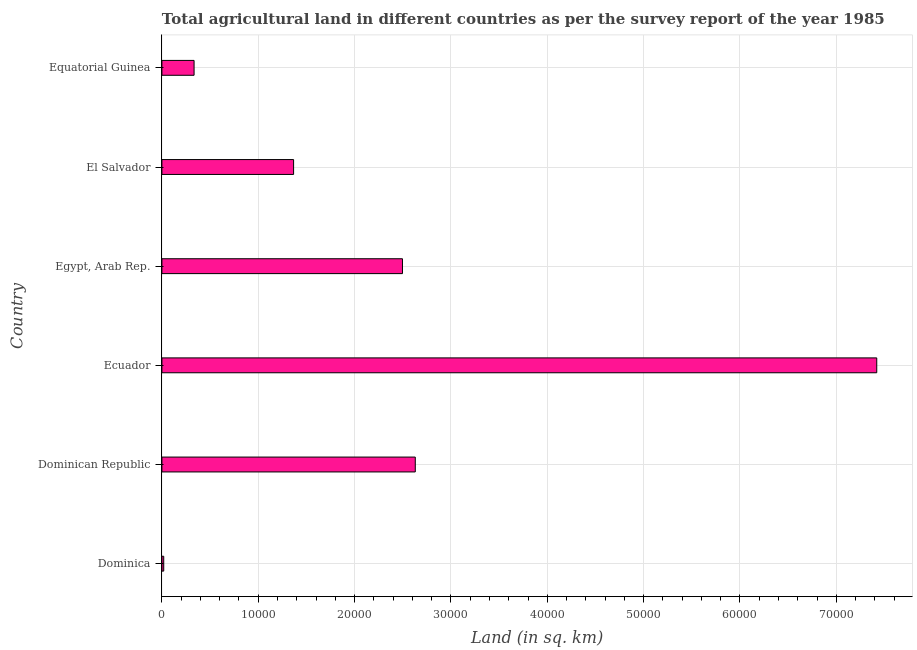Does the graph contain any zero values?
Give a very brief answer. No. What is the title of the graph?
Your response must be concise. Total agricultural land in different countries as per the survey report of the year 1985. What is the label or title of the X-axis?
Provide a short and direct response. Land (in sq. km). What is the agricultural land in El Salvador?
Offer a very short reply. 1.37e+04. Across all countries, what is the maximum agricultural land?
Make the answer very short. 7.42e+04. Across all countries, what is the minimum agricultural land?
Keep it short and to the point. 190. In which country was the agricultural land maximum?
Make the answer very short. Ecuador. In which country was the agricultural land minimum?
Provide a succinct answer. Dominica. What is the sum of the agricultural land?
Offer a very short reply. 1.43e+05. What is the difference between the agricultural land in Dominican Republic and El Salvador?
Provide a succinct answer. 1.26e+04. What is the average agricultural land per country?
Ensure brevity in your answer.  2.38e+04. What is the median agricultural land?
Offer a very short reply. 1.93e+04. In how many countries, is the agricultural land greater than 42000 sq. km?
Provide a succinct answer. 1. What is the ratio of the agricultural land in Egypt, Arab Rep. to that in El Salvador?
Offer a very short reply. 1.83. Is the agricultural land in Dominican Republic less than that in El Salvador?
Your answer should be very brief. No. What is the difference between the highest and the second highest agricultural land?
Keep it short and to the point. 4.79e+04. Is the sum of the agricultural land in Egypt, Arab Rep. and El Salvador greater than the maximum agricultural land across all countries?
Keep it short and to the point. No. What is the difference between the highest and the lowest agricultural land?
Provide a short and direct response. 7.40e+04. Are all the bars in the graph horizontal?
Give a very brief answer. Yes. What is the Land (in sq. km) in Dominica?
Give a very brief answer. 190. What is the Land (in sq. km) of Dominican Republic?
Provide a succinct answer. 2.63e+04. What is the Land (in sq. km) of Ecuador?
Your answer should be compact. 7.42e+04. What is the Land (in sq. km) of Egypt, Arab Rep.?
Your answer should be compact. 2.50e+04. What is the Land (in sq. km) in El Salvador?
Keep it short and to the point. 1.37e+04. What is the Land (in sq. km) of Equatorial Guinea?
Give a very brief answer. 3340. What is the difference between the Land (in sq. km) in Dominica and Dominican Republic?
Your response must be concise. -2.61e+04. What is the difference between the Land (in sq. km) in Dominica and Ecuador?
Provide a succinct answer. -7.40e+04. What is the difference between the Land (in sq. km) in Dominica and Egypt, Arab Rep.?
Give a very brief answer. -2.48e+04. What is the difference between the Land (in sq. km) in Dominica and El Salvador?
Your answer should be very brief. -1.35e+04. What is the difference between the Land (in sq. km) in Dominica and Equatorial Guinea?
Your answer should be compact. -3150. What is the difference between the Land (in sq. km) in Dominican Republic and Ecuador?
Give a very brief answer. -4.79e+04. What is the difference between the Land (in sq. km) in Dominican Republic and Egypt, Arab Rep.?
Provide a succinct answer. 1330. What is the difference between the Land (in sq. km) in Dominican Republic and El Salvador?
Keep it short and to the point. 1.26e+04. What is the difference between the Land (in sq. km) in Dominican Republic and Equatorial Guinea?
Provide a succinct answer. 2.30e+04. What is the difference between the Land (in sq. km) in Ecuador and Egypt, Arab Rep.?
Make the answer very short. 4.92e+04. What is the difference between the Land (in sq. km) in Ecuador and El Salvador?
Your response must be concise. 6.05e+04. What is the difference between the Land (in sq. km) in Ecuador and Equatorial Guinea?
Your response must be concise. 7.09e+04. What is the difference between the Land (in sq. km) in Egypt, Arab Rep. and El Salvador?
Give a very brief answer. 1.13e+04. What is the difference between the Land (in sq. km) in Egypt, Arab Rep. and Equatorial Guinea?
Keep it short and to the point. 2.16e+04. What is the difference between the Land (in sq. km) in El Salvador and Equatorial Guinea?
Your answer should be compact. 1.03e+04. What is the ratio of the Land (in sq. km) in Dominica to that in Dominican Republic?
Offer a very short reply. 0.01. What is the ratio of the Land (in sq. km) in Dominica to that in Ecuador?
Your answer should be very brief. 0. What is the ratio of the Land (in sq. km) in Dominica to that in Egypt, Arab Rep.?
Your response must be concise. 0.01. What is the ratio of the Land (in sq. km) in Dominica to that in El Salvador?
Ensure brevity in your answer.  0.01. What is the ratio of the Land (in sq. km) in Dominica to that in Equatorial Guinea?
Offer a terse response. 0.06. What is the ratio of the Land (in sq. km) in Dominican Republic to that in Ecuador?
Provide a succinct answer. 0.35. What is the ratio of the Land (in sq. km) in Dominican Republic to that in Egypt, Arab Rep.?
Your answer should be compact. 1.05. What is the ratio of the Land (in sq. km) in Dominican Republic to that in El Salvador?
Your response must be concise. 1.92. What is the ratio of the Land (in sq. km) in Dominican Republic to that in Equatorial Guinea?
Make the answer very short. 7.87. What is the ratio of the Land (in sq. km) in Ecuador to that in Egypt, Arab Rep.?
Provide a succinct answer. 2.97. What is the ratio of the Land (in sq. km) in Ecuador to that in El Salvador?
Offer a terse response. 5.43. What is the ratio of the Land (in sq. km) in Ecuador to that in Equatorial Guinea?
Provide a succinct answer. 22.22. What is the ratio of the Land (in sq. km) in Egypt, Arab Rep. to that in El Salvador?
Ensure brevity in your answer.  1.83. What is the ratio of the Land (in sq. km) in Egypt, Arab Rep. to that in Equatorial Guinea?
Your answer should be compact. 7.48. What is the ratio of the Land (in sq. km) in El Salvador to that in Equatorial Guinea?
Provide a succinct answer. 4.09. 